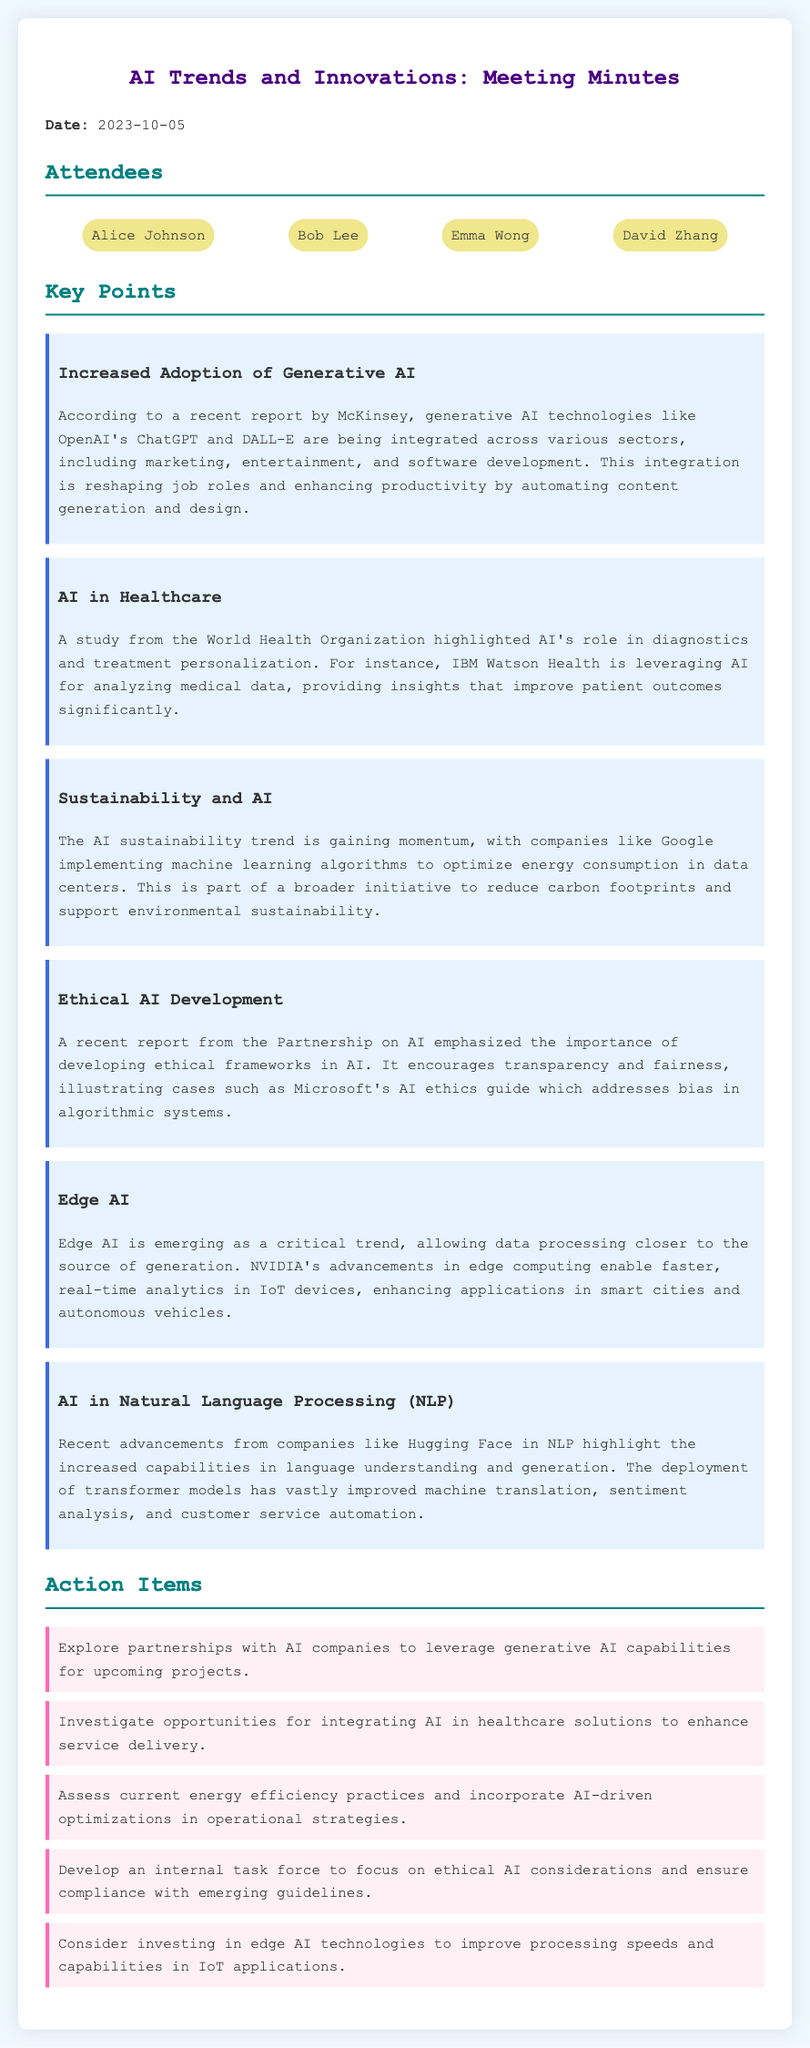what date was the meeting held? The date of the meeting is explicitly mentioned in the document as 2023-10-05.
Answer: 2023-10-05 who gave insights on increased adoption of generative AI? Insights on increased adoption of generative AI were provided in a report by McKinsey.
Answer: McKinsey which organization emphasized ethical AI development? The importance of ethical AI development was emphasized by the Partnership on AI.
Answer: Partnership on AI what AI technology is being implemented by Google for sustainability? Google is implementing machine learning algorithms for optimizing energy consumption in data centers.
Answer: machine learning algorithms name one application of edge AI mentioned in the document. The document mentions that edge AI enhances applications in smart cities and autonomous vehicles.
Answer: smart cities and autonomous vehicles how many attendees were listed in the meeting minutes? The total number of attendees is mentioned in the attendees section of the minutes.
Answer: 4 what is one action item related to healthcare solutions? One action item listed involves investigating opportunities for integrating AI in healthcare solutions.
Answer: Investigate opportunities for integrating AI in healthcare solutions which key point discusses advancements in Natural Language Processing? The key point discussing advancements in Natural Language Processing is labeled as "AI in Natural Language Processing (NLP)."
Answer: AI in Natural Language Processing (NLP) what is one of the sustainability trends mentioned? The document discusses AI sustainability trends gaining momentum, particularly mentioning energy optimization.
Answer: energy optimization 